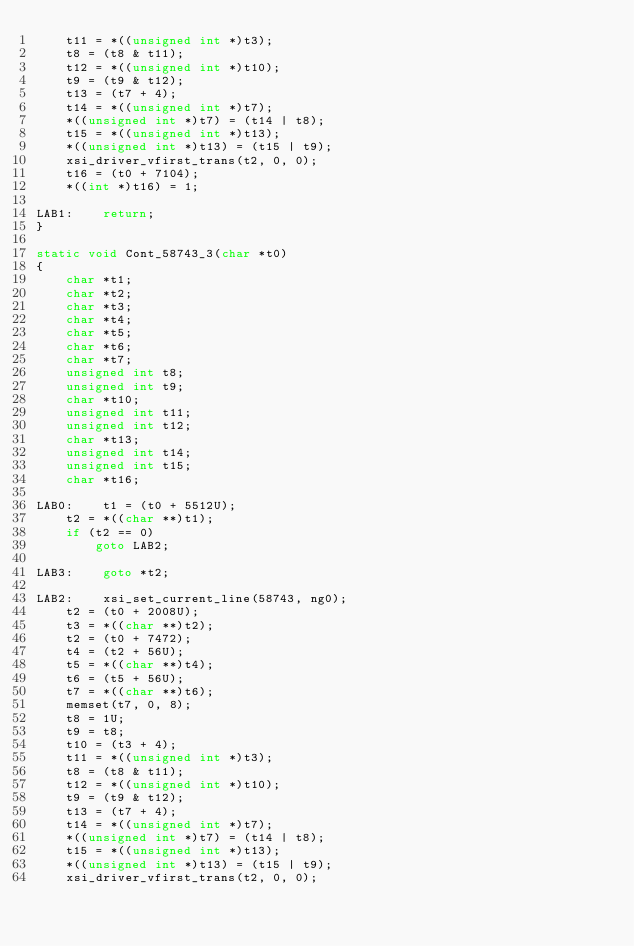Convert code to text. <code><loc_0><loc_0><loc_500><loc_500><_C_>    t11 = *((unsigned int *)t3);
    t8 = (t8 & t11);
    t12 = *((unsigned int *)t10);
    t9 = (t9 & t12);
    t13 = (t7 + 4);
    t14 = *((unsigned int *)t7);
    *((unsigned int *)t7) = (t14 | t8);
    t15 = *((unsigned int *)t13);
    *((unsigned int *)t13) = (t15 | t9);
    xsi_driver_vfirst_trans(t2, 0, 0);
    t16 = (t0 + 7104);
    *((int *)t16) = 1;

LAB1:    return;
}

static void Cont_58743_3(char *t0)
{
    char *t1;
    char *t2;
    char *t3;
    char *t4;
    char *t5;
    char *t6;
    char *t7;
    unsigned int t8;
    unsigned int t9;
    char *t10;
    unsigned int t11;
    unsigned int t12;
    char *t13;
    unsigned int t14;
    unsigned int t15;
    char *t16;

LAB0:    t1 = (t0 + 5512U);
    t2 = *((char **)t1);
    if (t2 == 0)
        goto LAB2;

LAB3:    goto *t2;

LAB2:    xsi_set_current_line(58743, ng0);
    t2 = (t0 + 2008U);
    t3 = *((char **)t2);
    t2 = (t0 + 7472);
    t4 = (t2 + 56U);
    t5 = *((char **)t4);
    t6 = (t5 + 56U);
    t7 = *((char **)t6);
    memset(t7, 0, 8);
    t8 = 1U;
    t9 = t8;
    t10 = (t3 + 4);
    t11 = *((unsigned int *)t3);
    t8 = (t8 & t11);
    t12 = *((unsigned int *)t10);
    t9 = (t9 & t12);
    t13 = (t7 + 4);
    t14 = *((unsigned int *)t7);
    *((unsigned int *)t7) = (t14 | t8);
    t15 = *((unsigned int *)t13);
    *((unsigned int *)t13) = (t15 | t9);
    xsi_driver_vfirst_trans(t2, 0, 0);</code> 